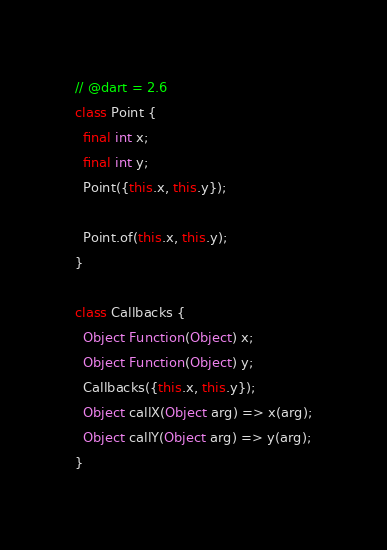Convert code to text. <code><loc_0><loc_0><loc_500><loc_500><_Dart_>// @dart = 2.6
class Point {
  final int x;
  final int y;
  Point({this.x, this.y});

  Point.of(this.x, this.y);
}

class Callbacks {
  Object Function(Object) x;
  Object Function(Object) y;
  Callbacks({this.x, this.y});
  Object callX(Object arg) => x(arg);
  Object callY(Object arg) => y(arg);
}
</code> 